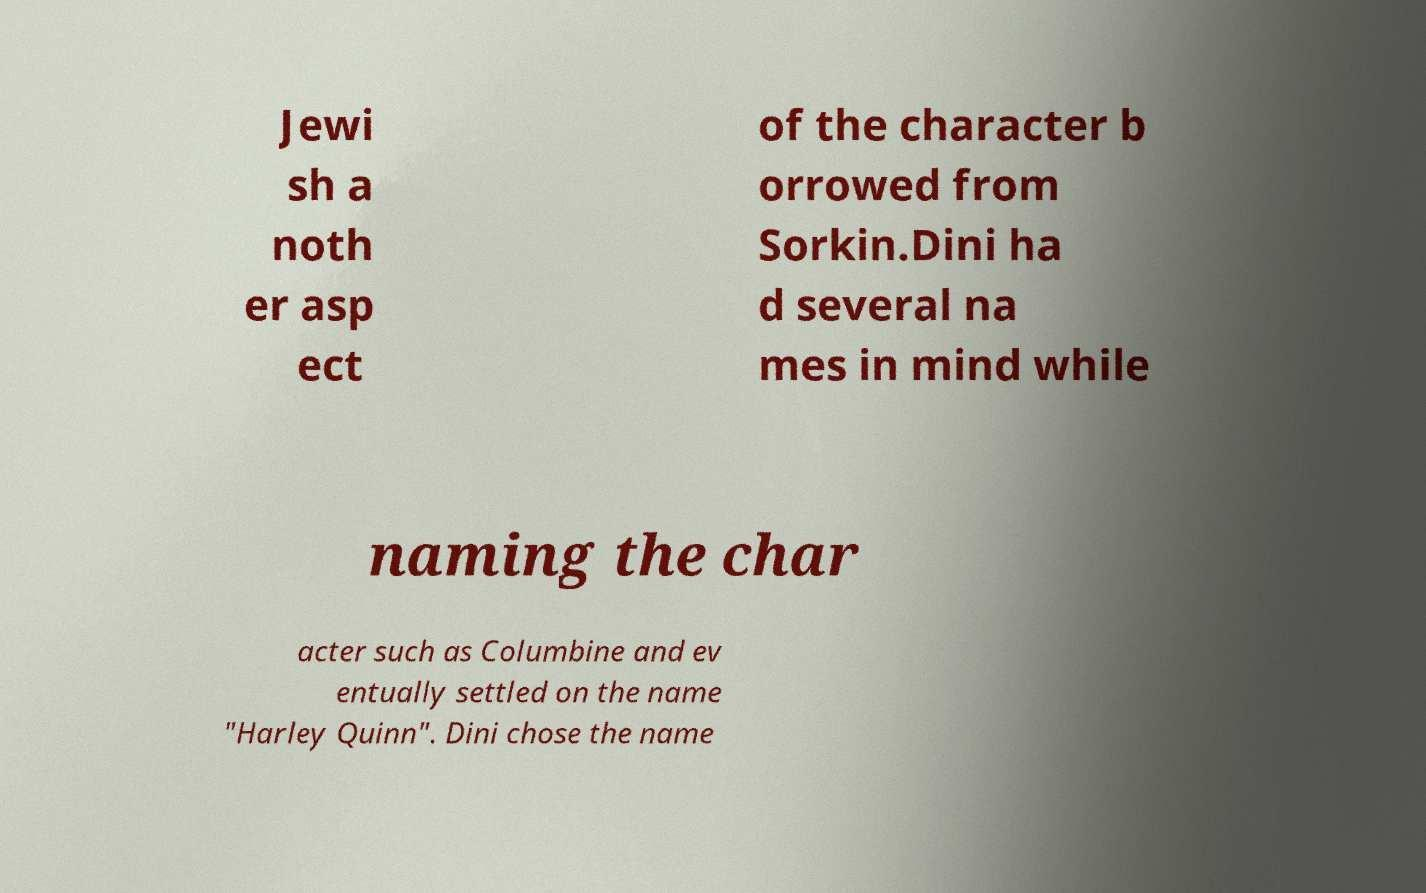Please identify and transcribe the text found in this image. Jewi sh a noth er asp ect of the character b orrowed from Sorkin.Dini ha d several na mes in mind while naming the char acter such as Columbine and ev entually settled on the name "Harley Quinn". Dini chose the name 